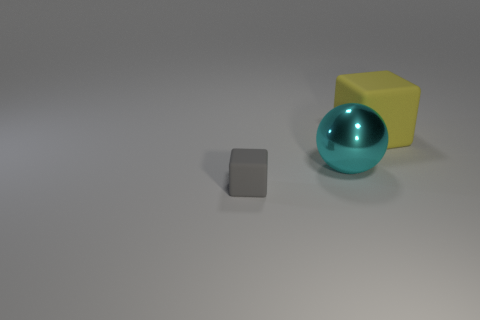There is a cube that is to the right of the large cyan metallic ball; is its color the same as the matte thing in front of the large yellow cube?
Offer a very short reply. No. Is there another object made of the same material as the large cyan thing?
Your answer should be compact. No. What is the size of the rubber cube that is to the right of the matte object in front of the yellow rubber thing?
Provide a succinct answer. Large. Is the number of large things greater than the number of tiny gray matte cubes?
Provide a succinct answer. Yes. Do the yellow rubber block that is behind the cyan metallic ball and the tiny gray cube have the same size?
Make the answer very short. No. Is the small gray rubber thing the same shape as the yellow thing?
Provide a short and direct response. Yes. Are there any other things that have the same size as the gray matte cube?
Keep it short and to the point. No. What is the size of the other object that is the same shape as the large rubber object?
Give a very brief answer. Small. Is the number of metallic balls that are behind the gray block greater than the number of things that are to the left of the yellow block?
Offer a terse response. No. Do the large yellow thing and the large object on the left side of the large block have the same material?
Your answer should be compact. No. 